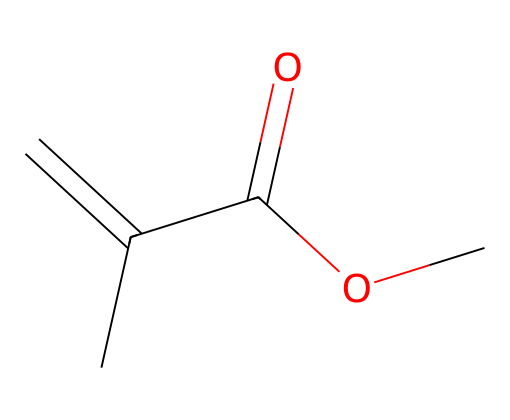What is the main functional group in methyl methacrylate? The structure shows a carbonyl (C=O) and an ester (C-O) functionality, which identifies it as an ester.
Answer: ester How many carbon atoms are present in methyl methacrylate? By examining the SMILES representation, there are five carbon atoms indicated in the structure (C=C(C)C(=O)OC).
Answer: five What type of chemical reaction is primarily associated with methyl methacrylate? Methyl methacrylate is commonly used in polymerization reactions to form polymethyl methacrylate, which is a type of addition polymerization.
Answer: addition polymerization What is the role of the double bond in the structure of methyl methacrylate? The double bond (C=C) provides reactivity that allows methyl methacrylate to undergo polymerization, leading to the formation of long-chain polymers.
Answer: reactivity for polymerization What is the molecular formula of methyl methacrylate? The molecular formula is derived from the count of each type of atom in the structure: C5H8O2.
Answer: C5H8O2 How does the presence of the ester functional group affect the solubility of methyl methacrylate? The ester group increases solubility in polar solvents due to its ability to interact through dipole interactions, making the substance more soluble in such environments.
Answer: increases solubility What is the state of methyl methacrylate at room temperature? The structure indicates that it is a liquid at room temperature, typically due to its low molecular weight and presence of polar functional groups.
Answer: liquid 